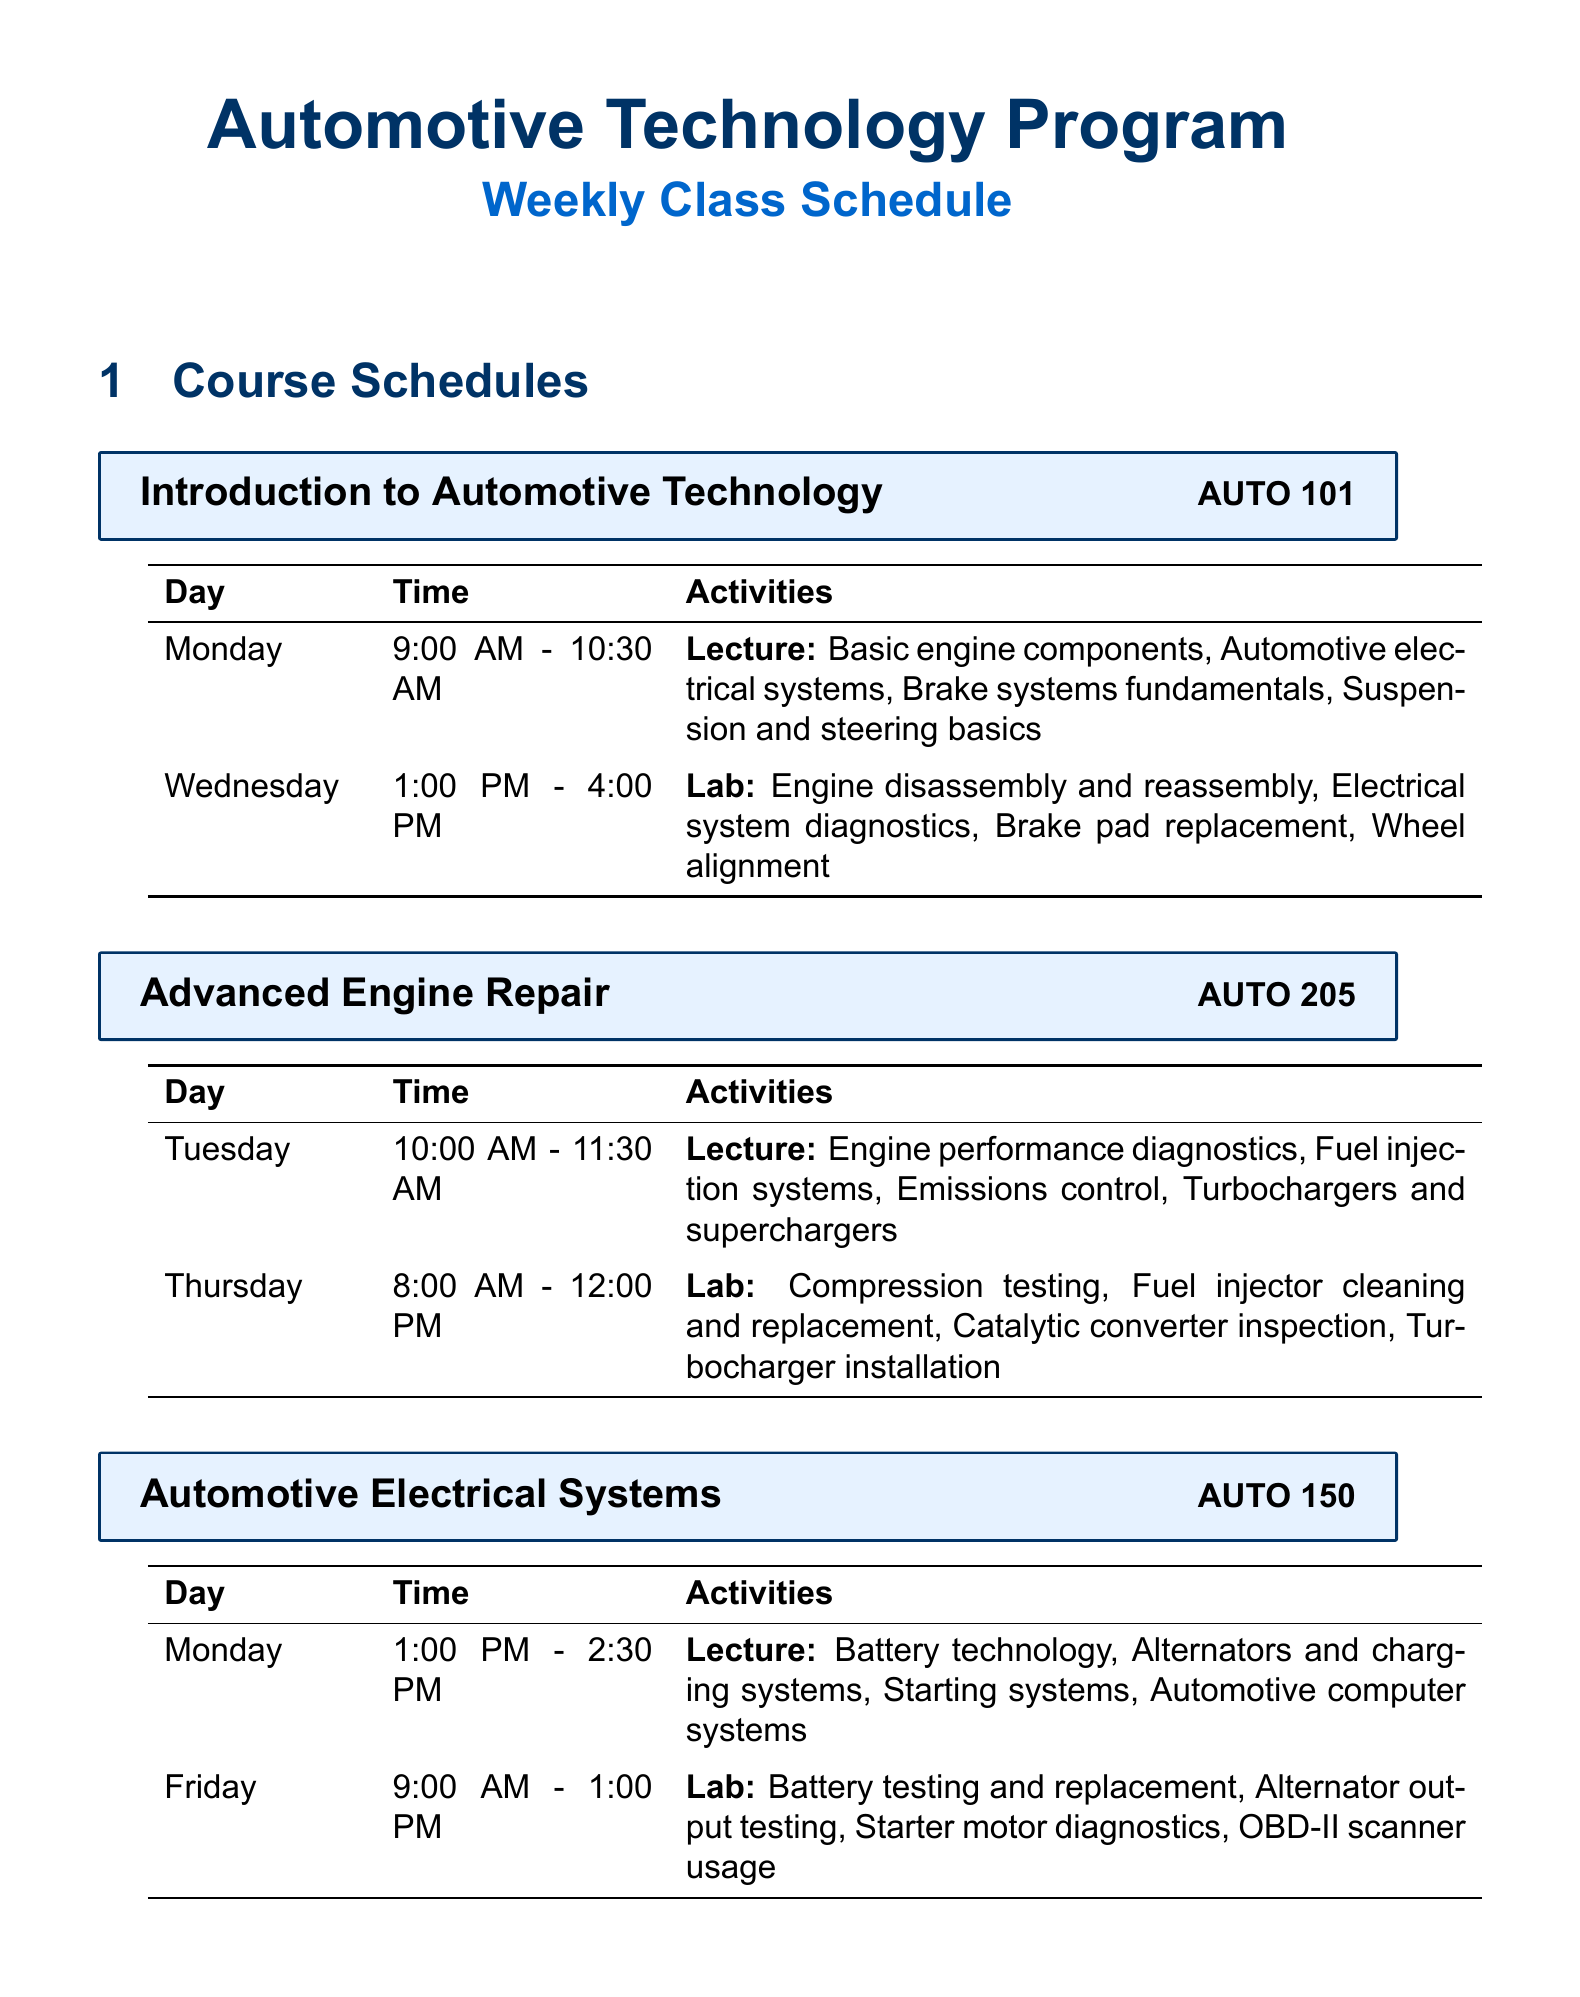what is the course code for Introduction to Automotive Technology? The course code is listed in the course header section for Introduction to Automotive Technology.
Answer: AUTO 101 how many weeks does the semester last? The document states the length of the semester in weeks at the beginning.
Answer: 16 what types of systems are covered in the Automotive Electrical Systems lecture? The topics covered in the lecture are listed in the weekly schedule for the course.
Answer: Battery technology, Alternators and charging systems, Starting systems, Automotive computer systems which lab activity takes place on Friday? The lab activities are detailed in the weekly schedule for Automotive Electrical Systems.
Answer: Battery testing and replacement, Alternator output testing, Starter motor diagnostics, OBD-II scanner usage on which day does the Brake and Suspension Systems lecture occur? The day for the lecture is specified in the weekly schedule for Brake and Suspension Systems.
Answer: Tuesday what is the duration of the Advanced Engine Repair lab session? The duration of the lab session can be calculated from the times listed in the weekly schedule for Advanced Engine Repair.
Answer: 4 hours which textbook covers automotive electricity and electronics? The textbooks section lists the titles and authors of the required textbooks.
Answer: Auto Electricity and Electronics how many lab sessions are scheduled for Introduction to Automotive Technology? The weekly schedule section details the frequency of lecture and lab sessions for each course.
Answer: 1 lab session 